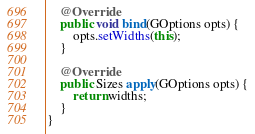Convert code to text. <code><loc_0><loc_0><loc_500><loc_500><_Java_>
    @Override
    public void bind(GOptions opts) {
        opts.setWidths(this);
    }

    @Override
    public Sizes apply(GOptions opts) {
        return widths;
    }
}
</code> 